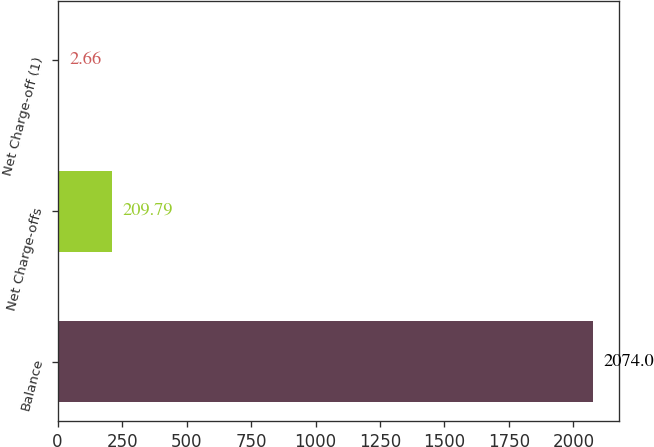Convert chart to OTSL. <chart><loc_0><loc_0><loc_500><loc_500><bar_chart><fcel>Balance<fcel>Net Charge-offs<fcel>Net Charge-off (1)<nl><fcel>2074<fcel>209.79<fcel>2.66<nl></chart> 